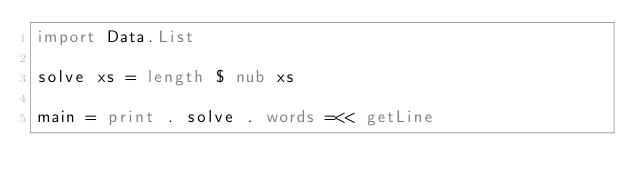<code> <loc_0><loc_0><loc_500><loc_500><_Haskell_>import Data.List

solve xs = length $ nub xs

main = print . solve . words =<< getLine
</code> 